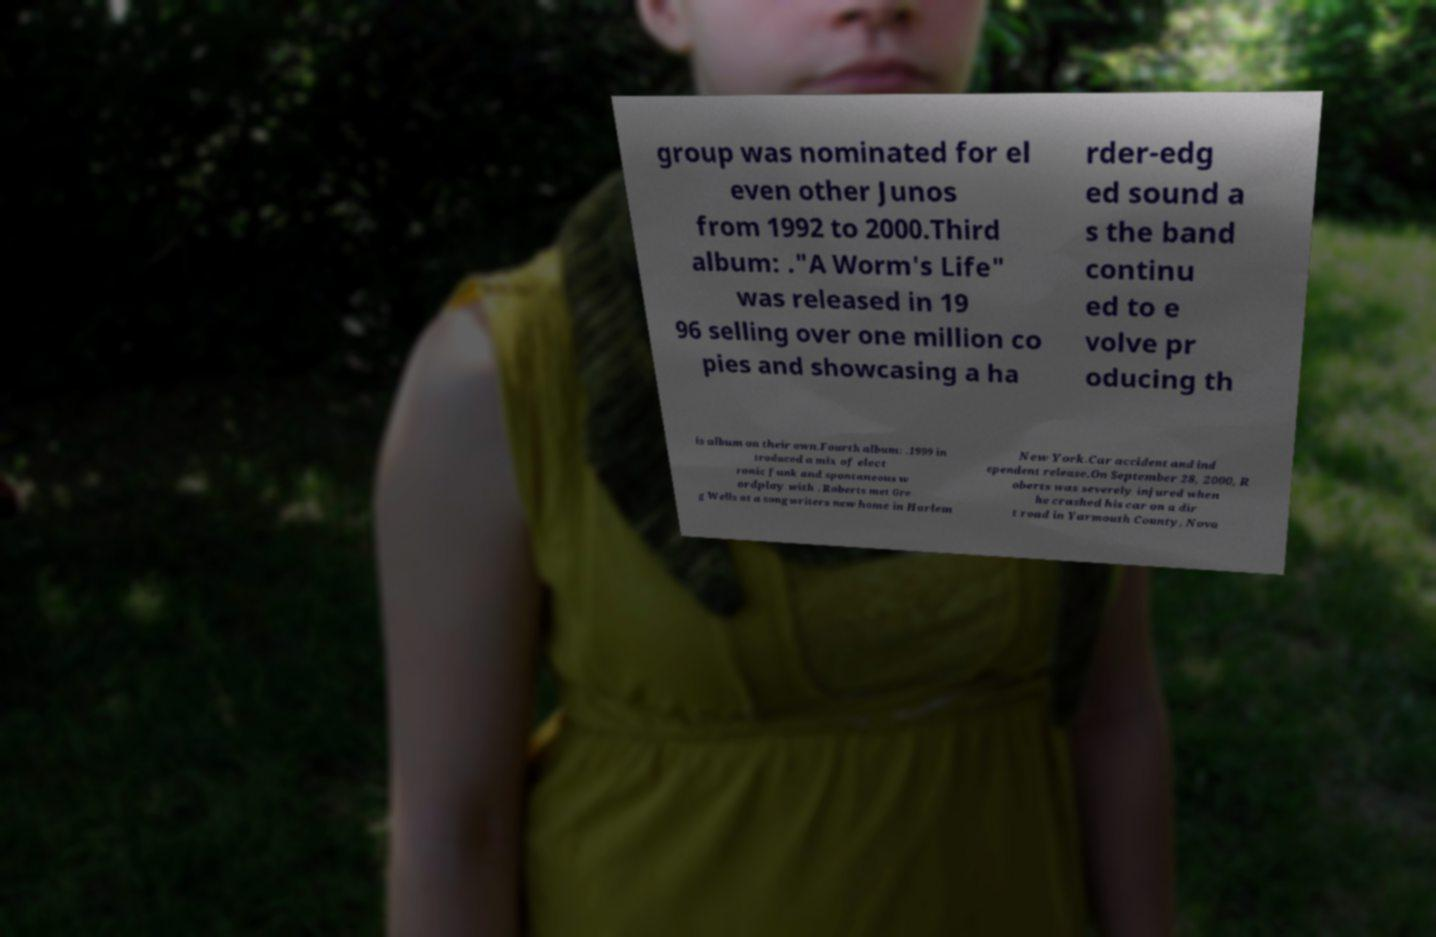I need the written content from this picture converted into text. Can you do that? group was nominated for el even other Junos from 1992 to 2000.Third album: ."A Worm's Life" was released in 19 96 selling over one million co pies and showcasing a ha rder-edg ed sound a s the band continu ed to e volve pr oducing th is album on their own.Fourth album: .1999 in troduced a mix of elect ronic funk and spontaneous w ordplay with . Roberts met Gre g Wells at a songwriters new home in Harlem New York.Car accident and ind ependent release.On September 28, 2000, R oberts was severely injured when he crashed his car on a dir t road in Yarmouth County, Nova 